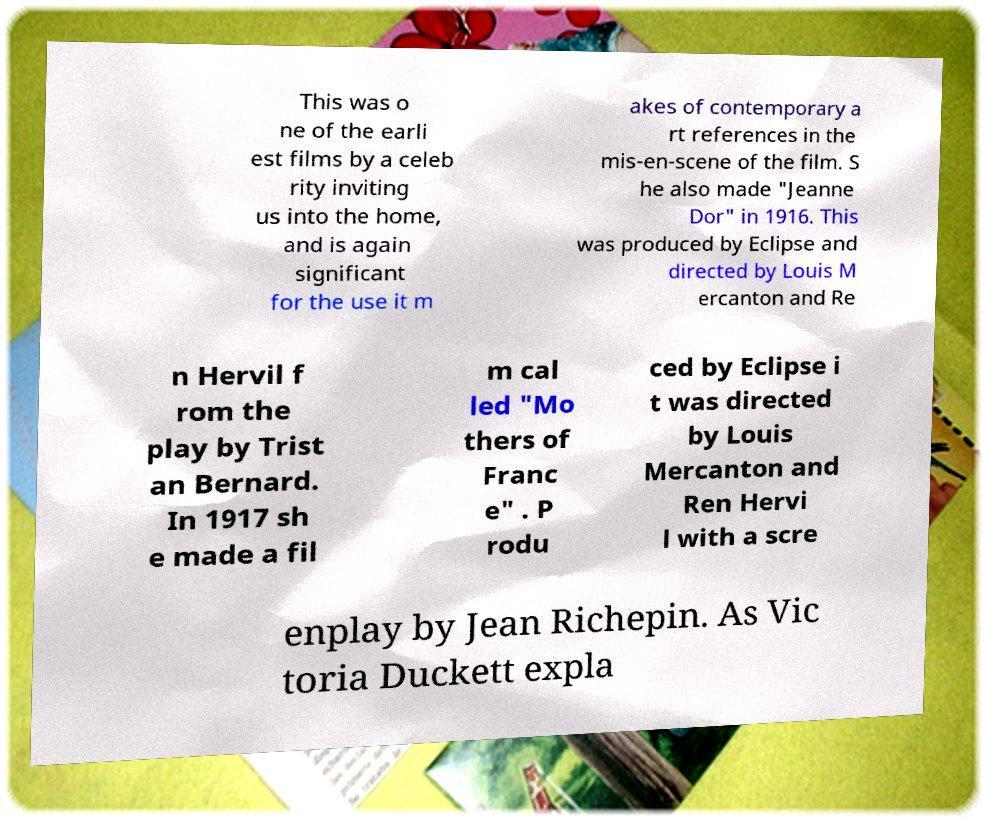What messages or text are displayed in this image? I need them in a readable, typed format. This was o ne of the earli est films by a celeb rity inviting us into the home, and is again significant for the use it m akes of contemporary a rt references in the mis-en-scene of the film. S he also made "Jeanne Dor" in 1916. This was produced by Eclipse and directed by Louis M ercanton and Re n Hervil f rom the play by Trist an Bernard. In 1917 sh e made a fil m cal led "Mo thers of Franc e" . P rodu ced by Eclipse i t was directed by Louis Mercanton and Ren Hervi l with a scre enplay by Jean Richepin. As Vic toria Duckett expla 